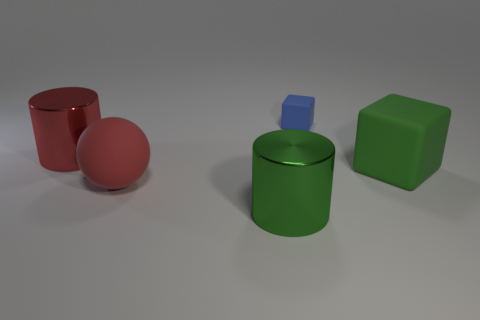Is there any other thing that has the same size as the blue thing?
Keep it short and to the point. No. The metal cylinder that is the same color as the large cube is what size?
Ensure brevity in your answer.  Large. There is a metallic object that is behind the big sphere; is its color the same as the matte thing that is left of the tiny blue object?
Provide a short and direct response. Yes. The green rubber object has what size?
Offer a terse response. Large. What number of small things are either metallic cylinders or red spheres?
Your answer should be compact. 0. What color is the metal thing that is the same size as the green cylinder?
Keep it short and to the point. Red. What number of other objects are the same shape as the big red matte object?
Make the answer very short. 0. Are there any green things that have the same material as the red cylinder?
Give a very brief answer. Yes. Are the red object that is behind the green rubber object and the green thing behind the sphere made of the same material?
Your answer should be compact. No. What number of tiny green rubber things are there?
Your answer should be very brief. 0. 